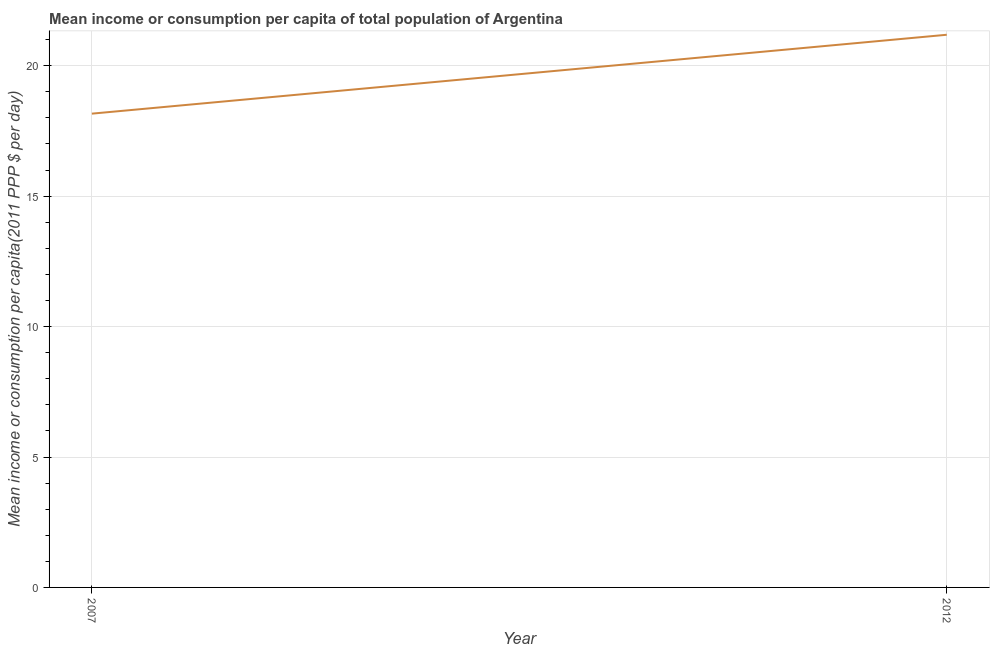What is the mean income or consumption in 2012?
Your response must be concise. 21.19. Across all years, what is the maximum mean income or consumption?
Ensure brevity in your answer.  21.19. Across all years, what is the minimum mean income or consumption?
Make the answer very short. 18.16. In which year was the mean income or consumption maximum?
Keep it short and to the point. 2012. In which year was the mean income or consumption minimum?
Offer a terse response. 2007. What is the sum of the mean income or consumption?
Your answer should be very brief. 39.35. What is the difference between the mean income or consumption in 2007 and 2012?
Provide a short and direct response. -3.02. What is the average mean income or consumption per year?
Your answer should be compact. 19.68. What is the median mean income or consumption?
Give a very brief answer. 19.68. What is the ratio of the mean income or consumption in 2007 to that in 2012?
Provide a succinct answer. 0.86. Is the mean income or consumption in 2007 less than that in 2012?
Your answer should be compact. Yes. How many lines are there?
Make the answer very short. 1. How many years are there in the graph?
Give a very brief answer. 2. What is the difference between two consecutive major ticks on the Y-axis?
Offer a very short reply. 5. Does the graph contain any zero values?
Your answer should be compact. No. Does the graph contain grids?
Offer a terse response. Yes. What is the title of the graph?
Your answer should be very brief. Mean income or consumption per capita of total population of Argentina. What is the label or title of the X-axis?
Provide a succinct answer. Year. What is the label or title of the Y-axis?
Your answer should be compact. Mean income or consumption per capita(2011 PPP $ per day). What is the Mean income or consumption per capita(2011 PPP $ per day) of 2007?
Offer a very short reply. 18.16. What is the Mean income or consumption per capita(2011 PPP $ per day) of 2012?
Provide a succinct answer. 21.19. What is the difference between the Mean income or consumption per capita(2011 PPP $ per day) in 2007 and 2012?
Keep it short and to the point. -3.02. What is the ratio of the Mean income or consumption per capita(2011 PPP $ per day) in 2007 to that in 2012?
Provide a succinct answer. 0.86. 